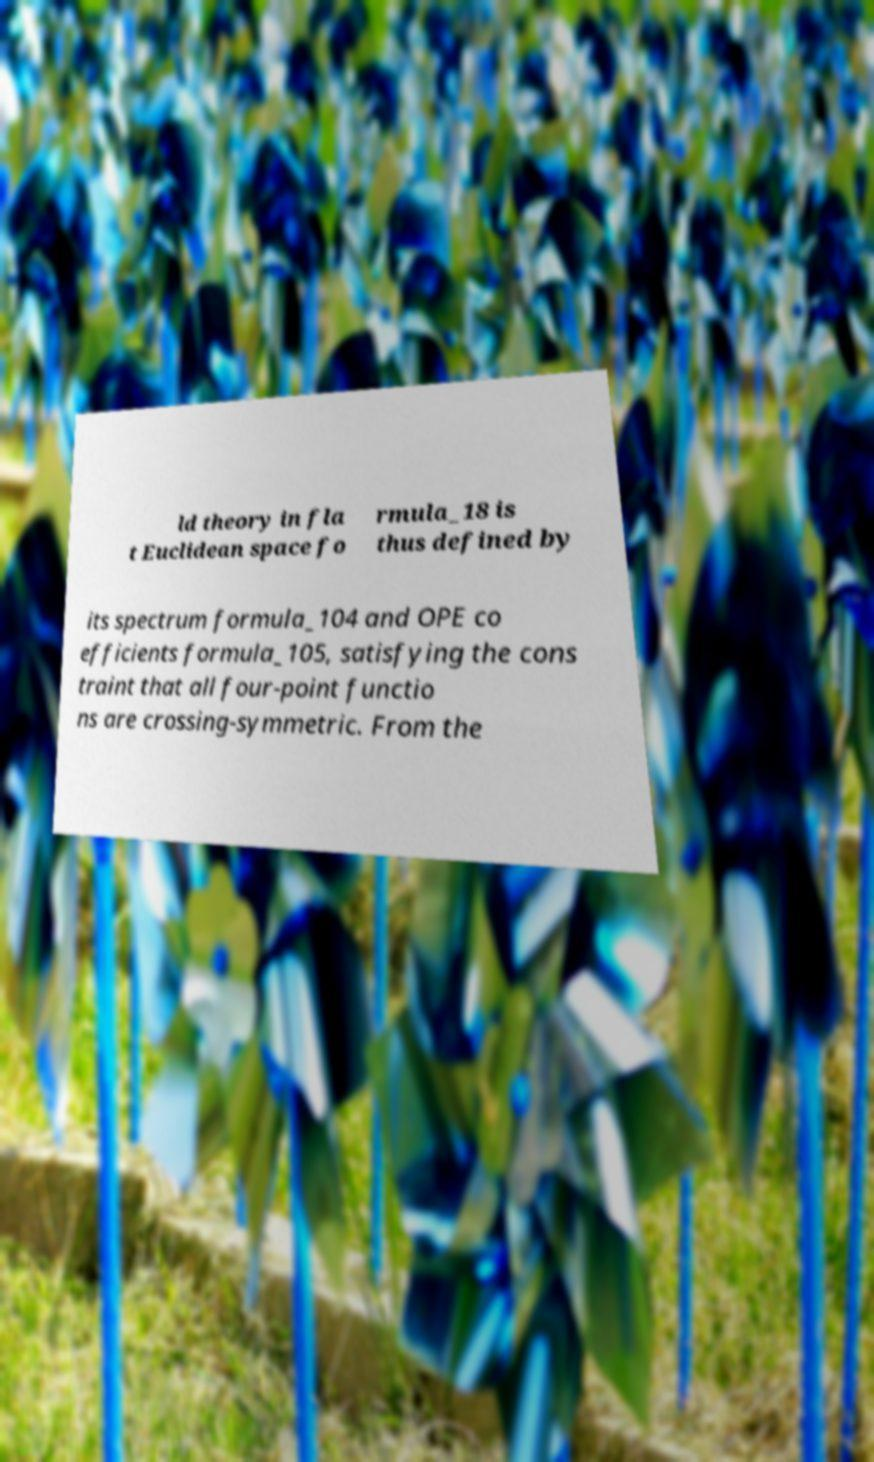Please read and relay the text visible in this image. What does it say? ld theory in fla t Euclidean space fo rmula_18 is thus defined by its spectrum formula_104 and OPE co efficients formula_105, satisfying the cons traint that all four-point functio ns are crossing-symmetric. From the 